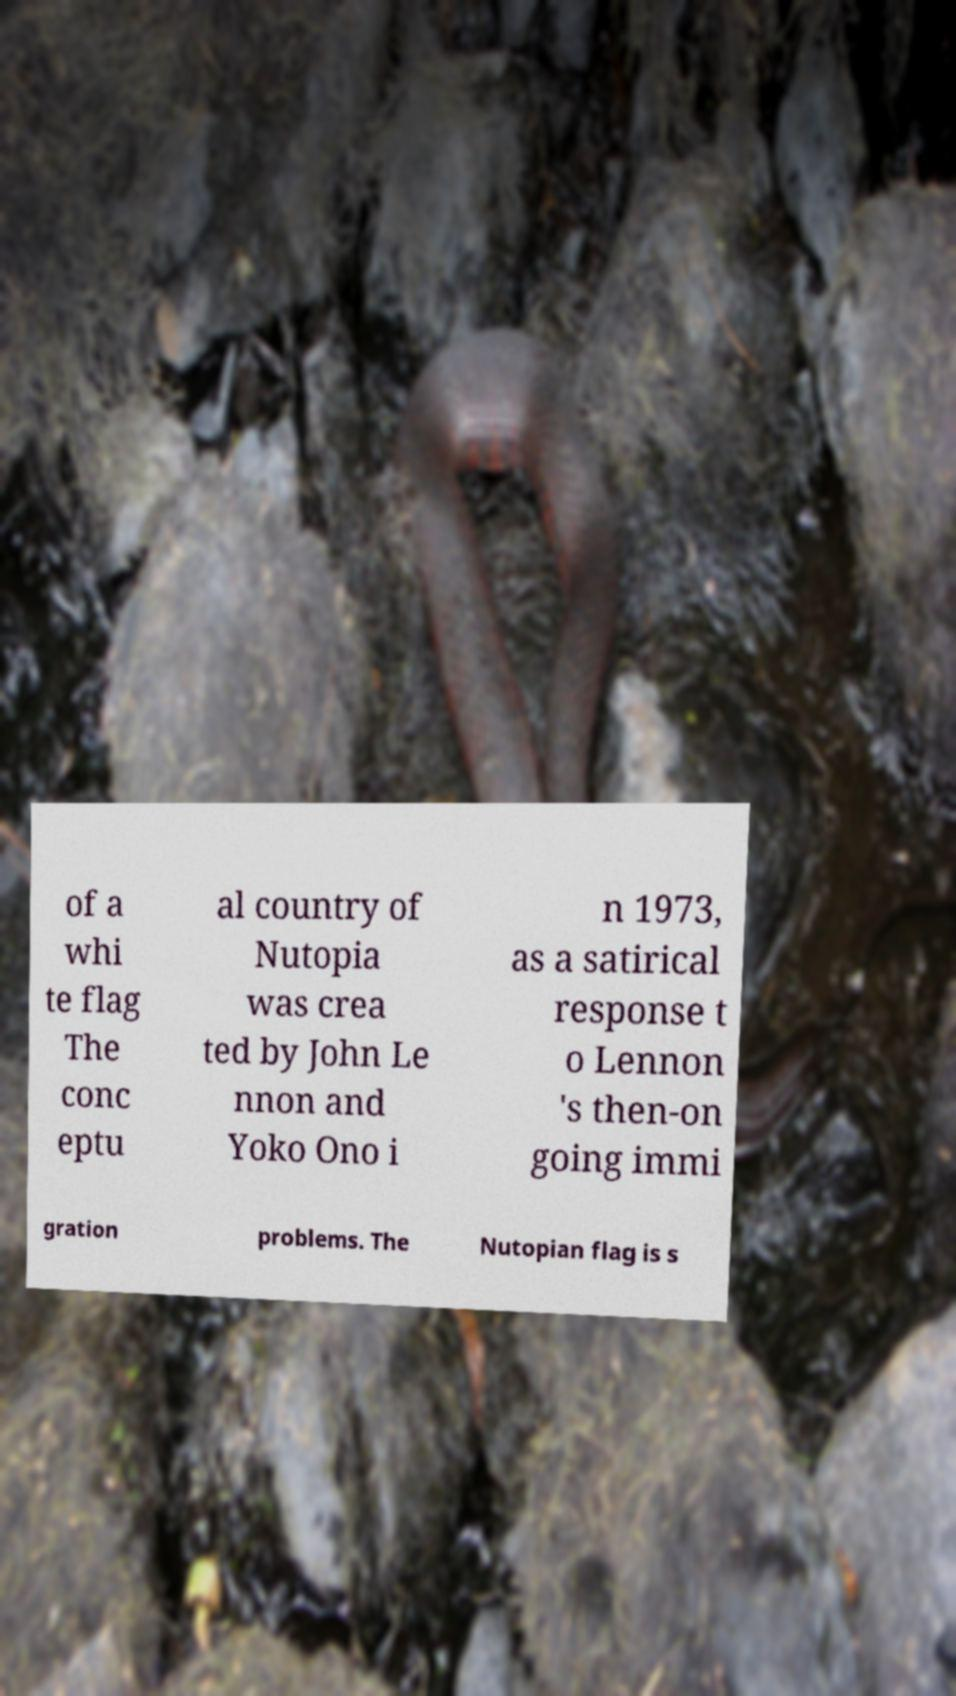Can you read and provide the text displayed in the image?This photo seems to have some interesting text. Can you extract and type it out for me? of a whi te flag The conc eptu al country of Nutopia was crea ted by John Le nnon and Yoko Ono i n 1973, as a satirical response t o Lennon 's then-on going immi gration problems. The Nutopian flag is s 